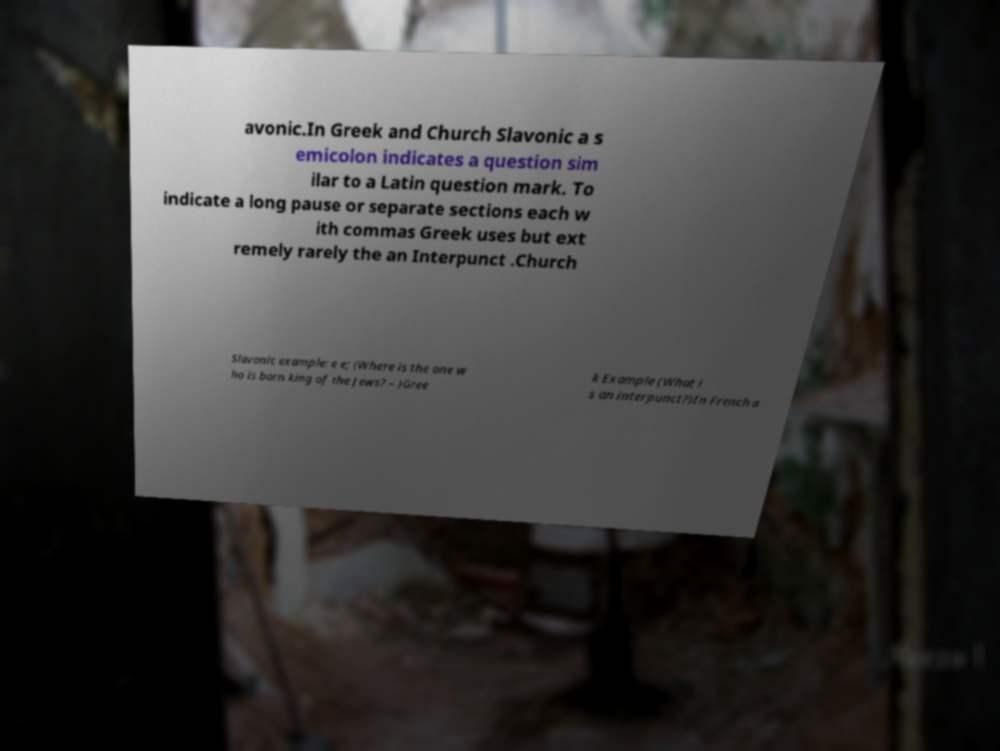Could you extract and type out the text from this image? avonic.In Greek and Church Slavonic a s emicolon indicates a question sim ilar to a Latin question mark. To indicate a long pause or separate sections each w ith commas Greek uses but ext remely rarely the an Interpunct .Church Slavonic example: e e; (Where is the one w ho is born king of the Jews? – )Gree k Example (What i s an interpunct?)In French a 